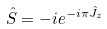Convert formula to latex. <formula><loc_0><loc_0><loc_500><loc_500>\hat { S } = - i e ^ { - i \pi \hat { J } _ { z } }</formula> 